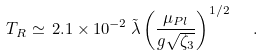<formula> <loc_0><loc_0><loc_500><loc_500>T _ { R } \simeq \, 2 . 1 \times 1 0 ^ { - 2 } \, \tilde { \lambda } \left ( \frac { \mu _ { P l } } { g \sqrt { \zeta _ { 3 } } } \right ) ^ { 1 / 2 } \ \ .</formula> 